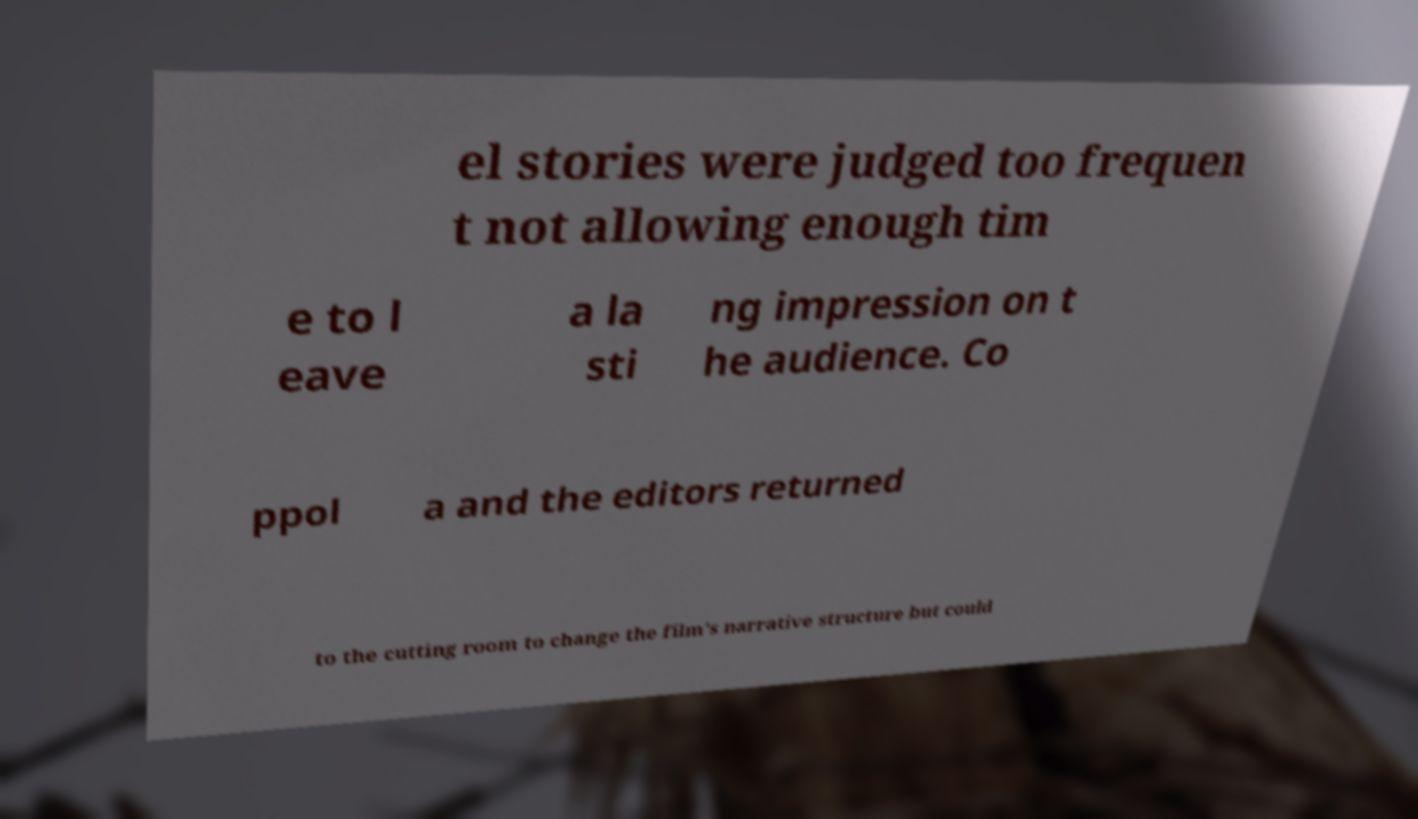Can you accurately transcribe the text from the provided image for me? el stories were judged too frequen t not allowing enough tim e to l eave a la sti ng impression on t he audience. Co ppol a and the editors returned to the cutting room to change the film's narrative structure but could 